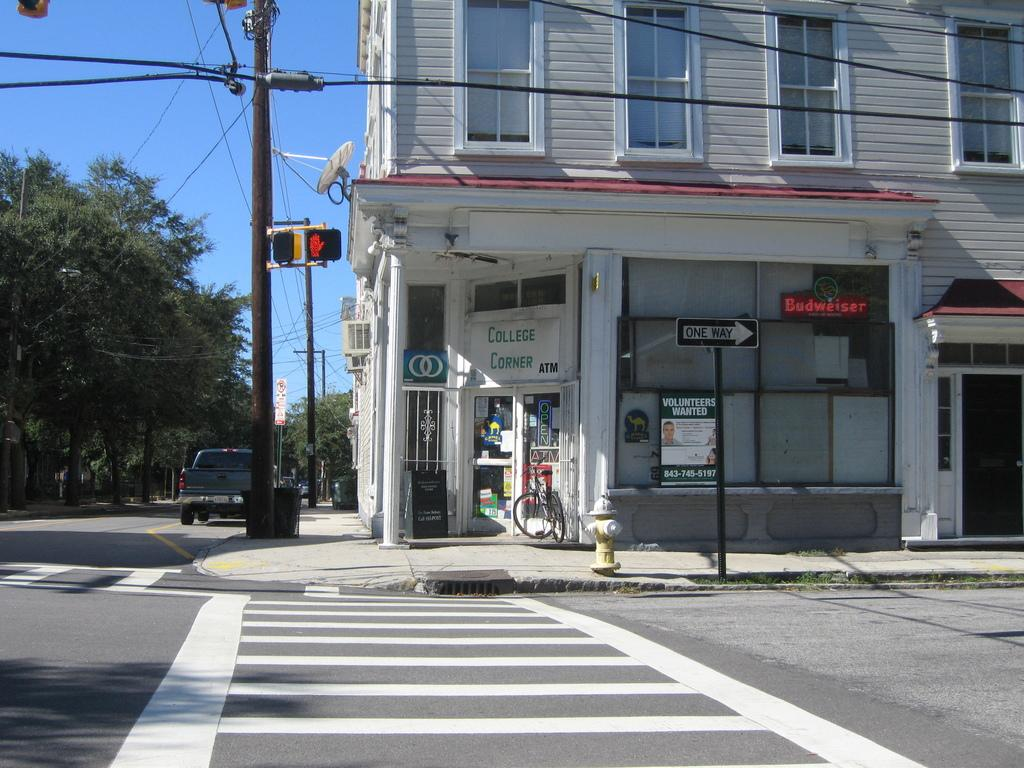<image>
Render a clear and concise summary of the photo. The college corner store has an ATM and has a license to sell beers like Budweiser. 